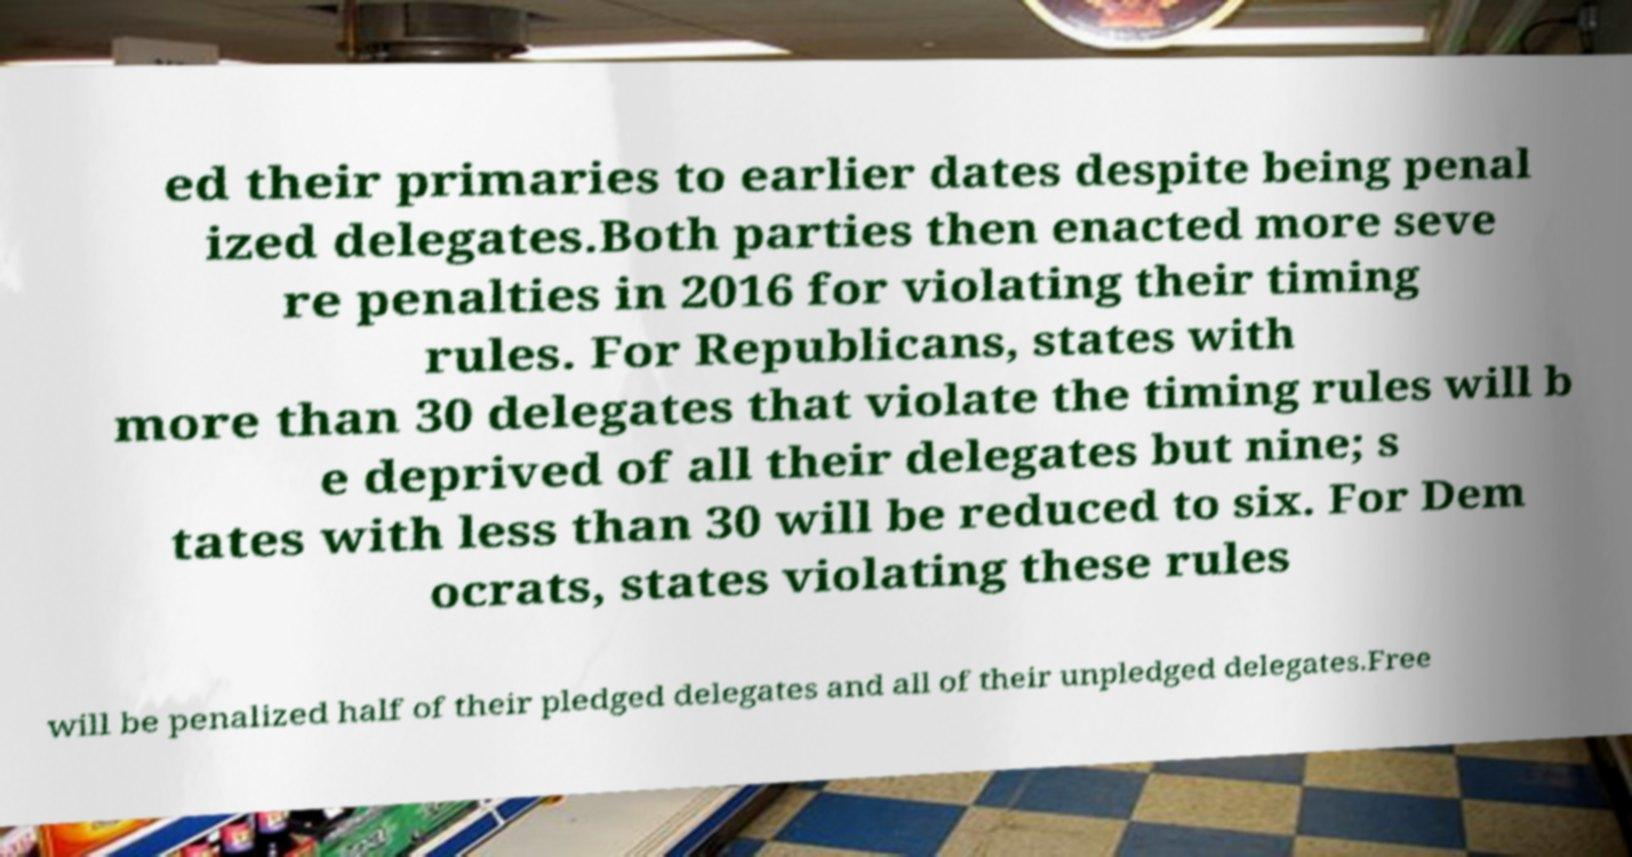For documentation purposes, I need the text within this image transcribed. Could you provide that? ed their primaries to earlier dates despite being penal ized delegates.Both parties then enacted more seve re penalties in 2016 for violating their timing rules. For Republicans, states with more than 30 delegates that violate the timing rules will b e deprived of all their delegates but nine; s tates with less than 30 will be reduced to six. For Dem ocrats, states violating these rules will be penalized half of their pledged delegates and all of their unpledged delegates.Free 